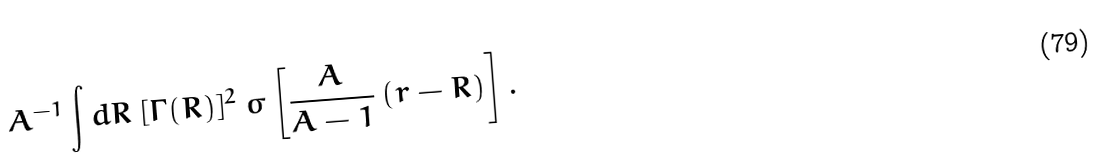Convert formula to latex. <formula><loc_0><loc_0><loc_500><loc_500>A ^ { - 1 } \int d R \ [ \Gamma ( R ) ] ^ { 2 } \ \sigma \left [ \frac { A } { A - 1 } \, ( r - R ) \right ] .</formula> 